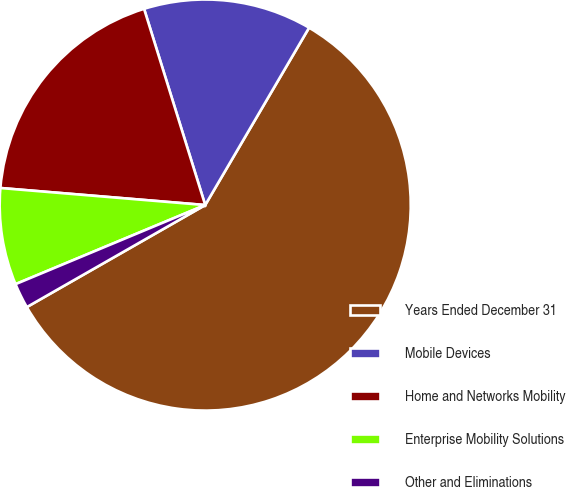Convert chart. <chart><loc_0><loc_0><loc_500><loc_500><pie_chart><fcel>Years Ended December 31<fcel>Mobile Devices<fcel>Home and Networks Mobility<fcel>Enterprise Mobility Solutions<fcel>Other and Eliminations<nl><fcel>58.3%<fcel>13.24%<fcel>18.87%<fcel>7.61%<fcel>1.98%<nl></chart> 